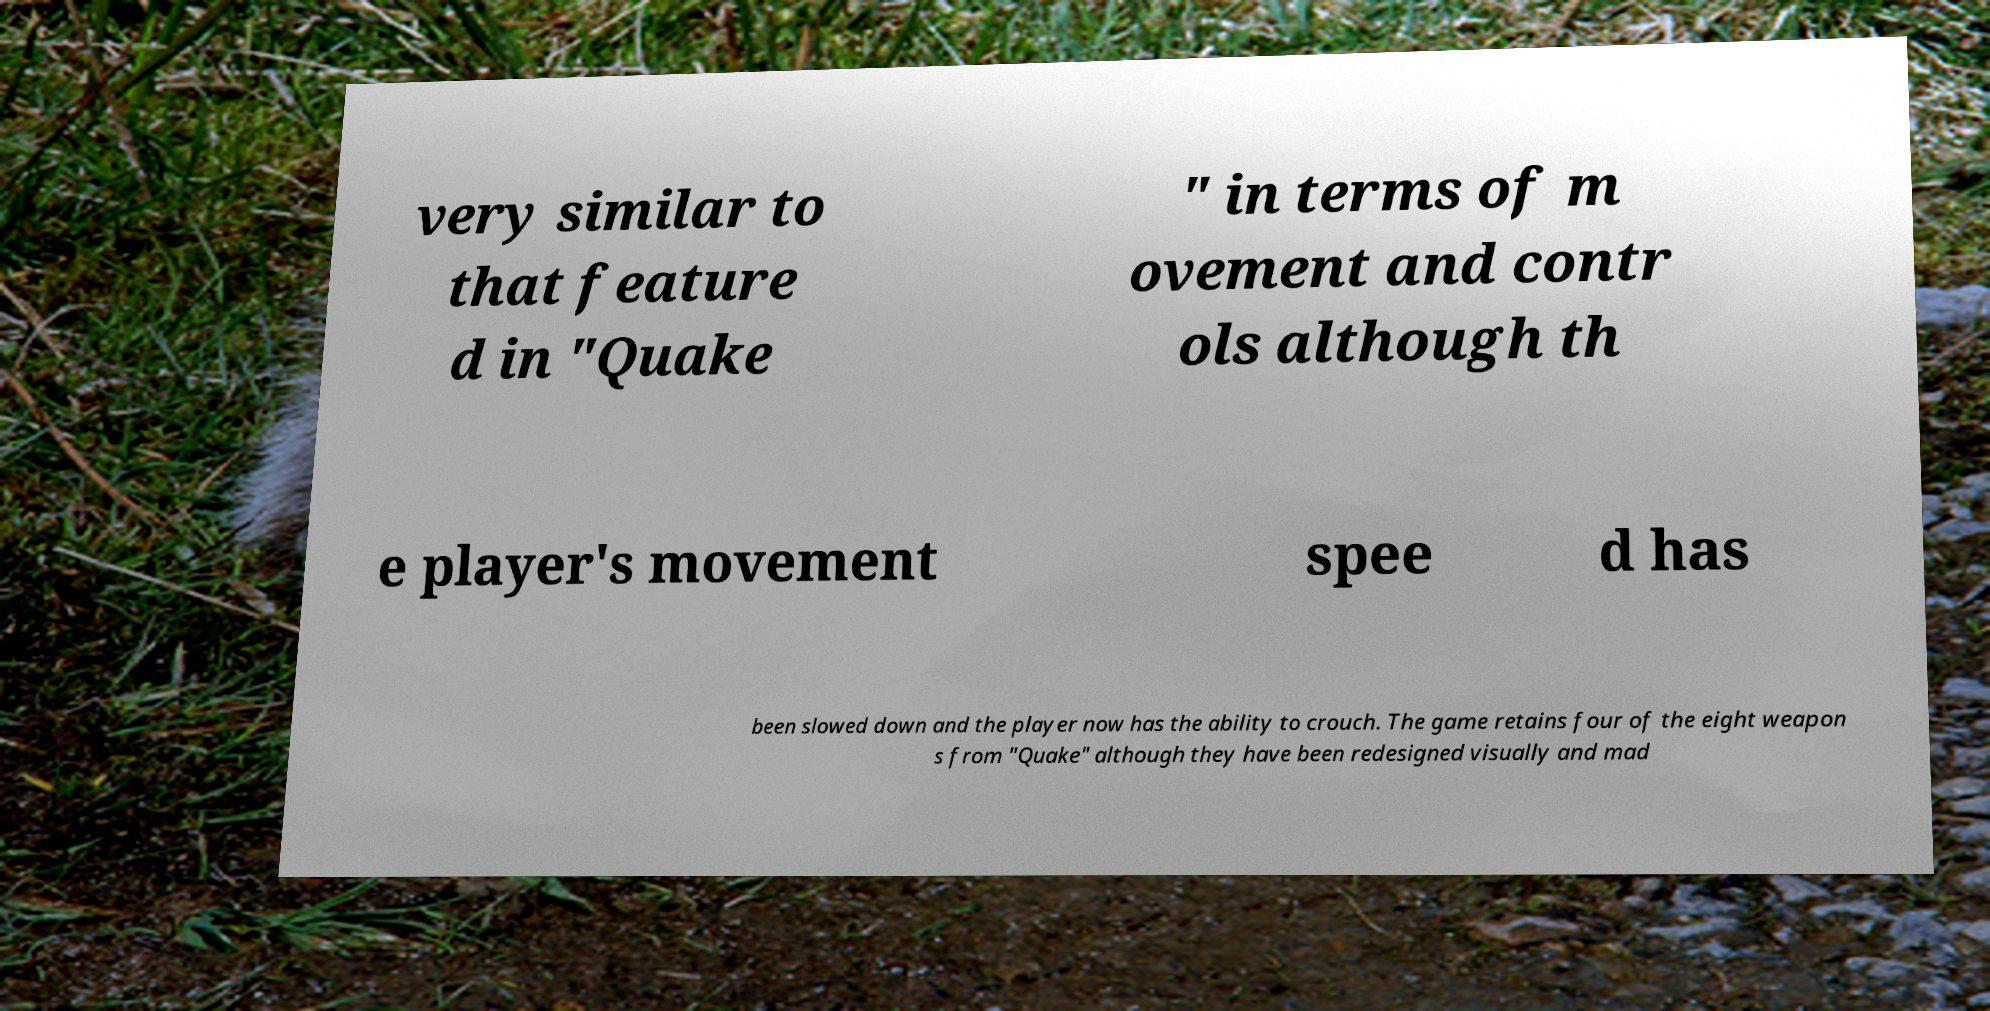There's text embedded in this image that I need extracted. Can you transcribe it verbatim? very similar to that feature d in "Quake " in terms of m ovement and contr ols although th e player's movement spee d has been slowed down and the player now has the ability to crouch. The game retains four of the eight weapon s from "Quake" although they have been redesigned visually and mad 